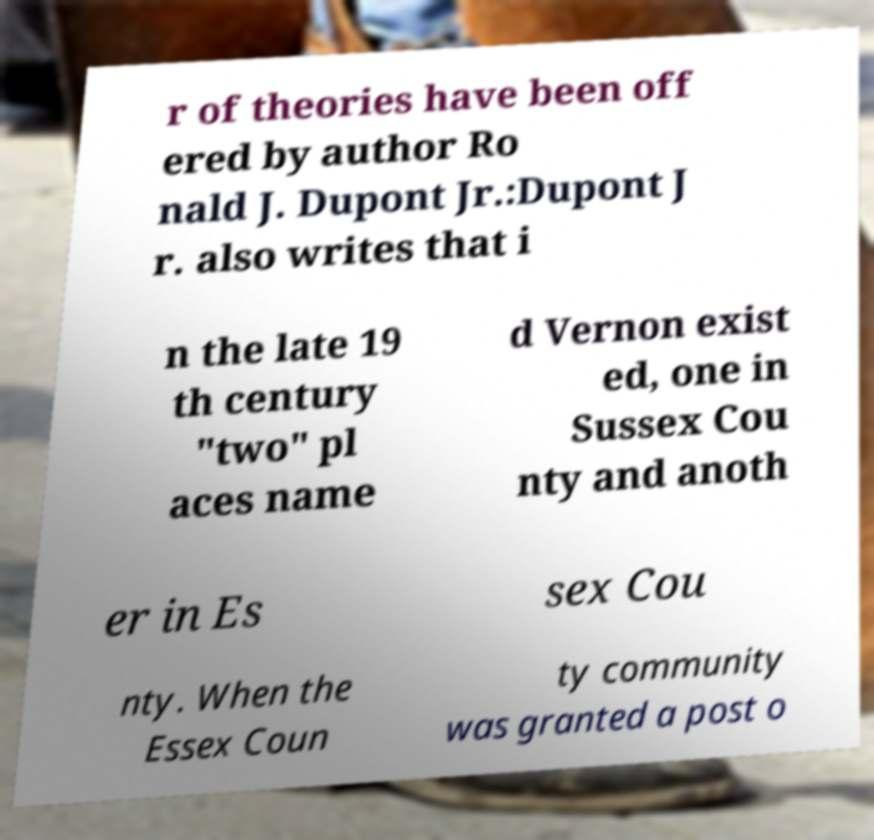I need the written content from this picture converted into text. Can you do that? r of theories have been off ered by author Ro nald J. Dupont Jr.:Dupont J r. also writes that i n the late 19 th century "two" pl aces name d Vernon exist ed, one in Sussex Cou nty and anoth er in Es sex Cou nty. When the Essex Coun ty community was granted a post o 